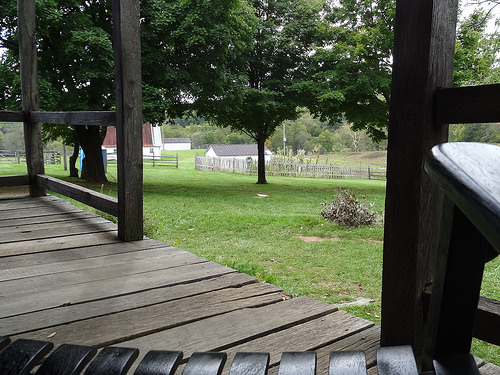<image>
Is the tree in the grass? No. The tree is not contained within the grass. These objects have a different spatial relationship. 